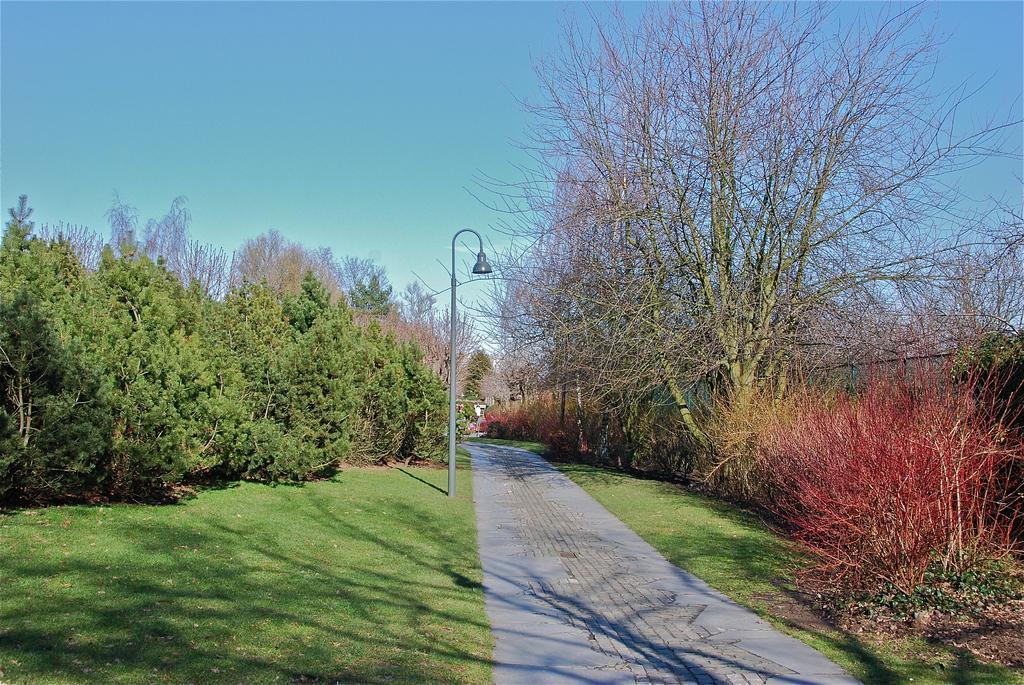Can you describe this image briefly? These are the trees and bushes. Here is the grass. This looks like a pathway. I think this is the street light. 